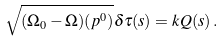Convert formula to latex. <formula><loc_0><loc_0><loc_500><loc_500>\sqrt { ( \Omega _ { 0 } - \Omega ) ( { p } ^ { 0 } ) } \delta { \tau } ( s ) = k { Q } ( s ) \, .</formula> 